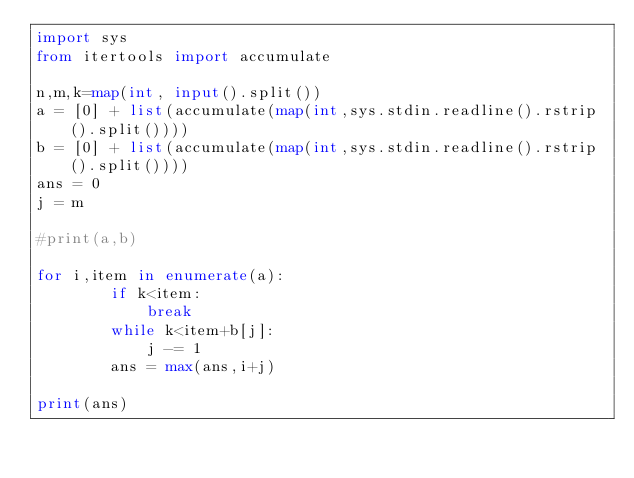Convert code to text. <code><loc_0><loc_0><loc_500><loc_500><_Python_>import sys
from itertools import accumulate

n,m,k=map(int, input().split())
a = [0] + list(accumulate(map(int,sys.stdin.readline().rstrip().split())))
b = [0] + list(accumulate(map(int,sys.stdin.readline().rstrip().split())))
ans = 0
j = m

#print(a,b)

for i,item in enumerate(a):
        if k<item:
            break
        while k<item+b[j]:
            j -= 1
        ans = max(ans,i+j)

print(ans)</code> 